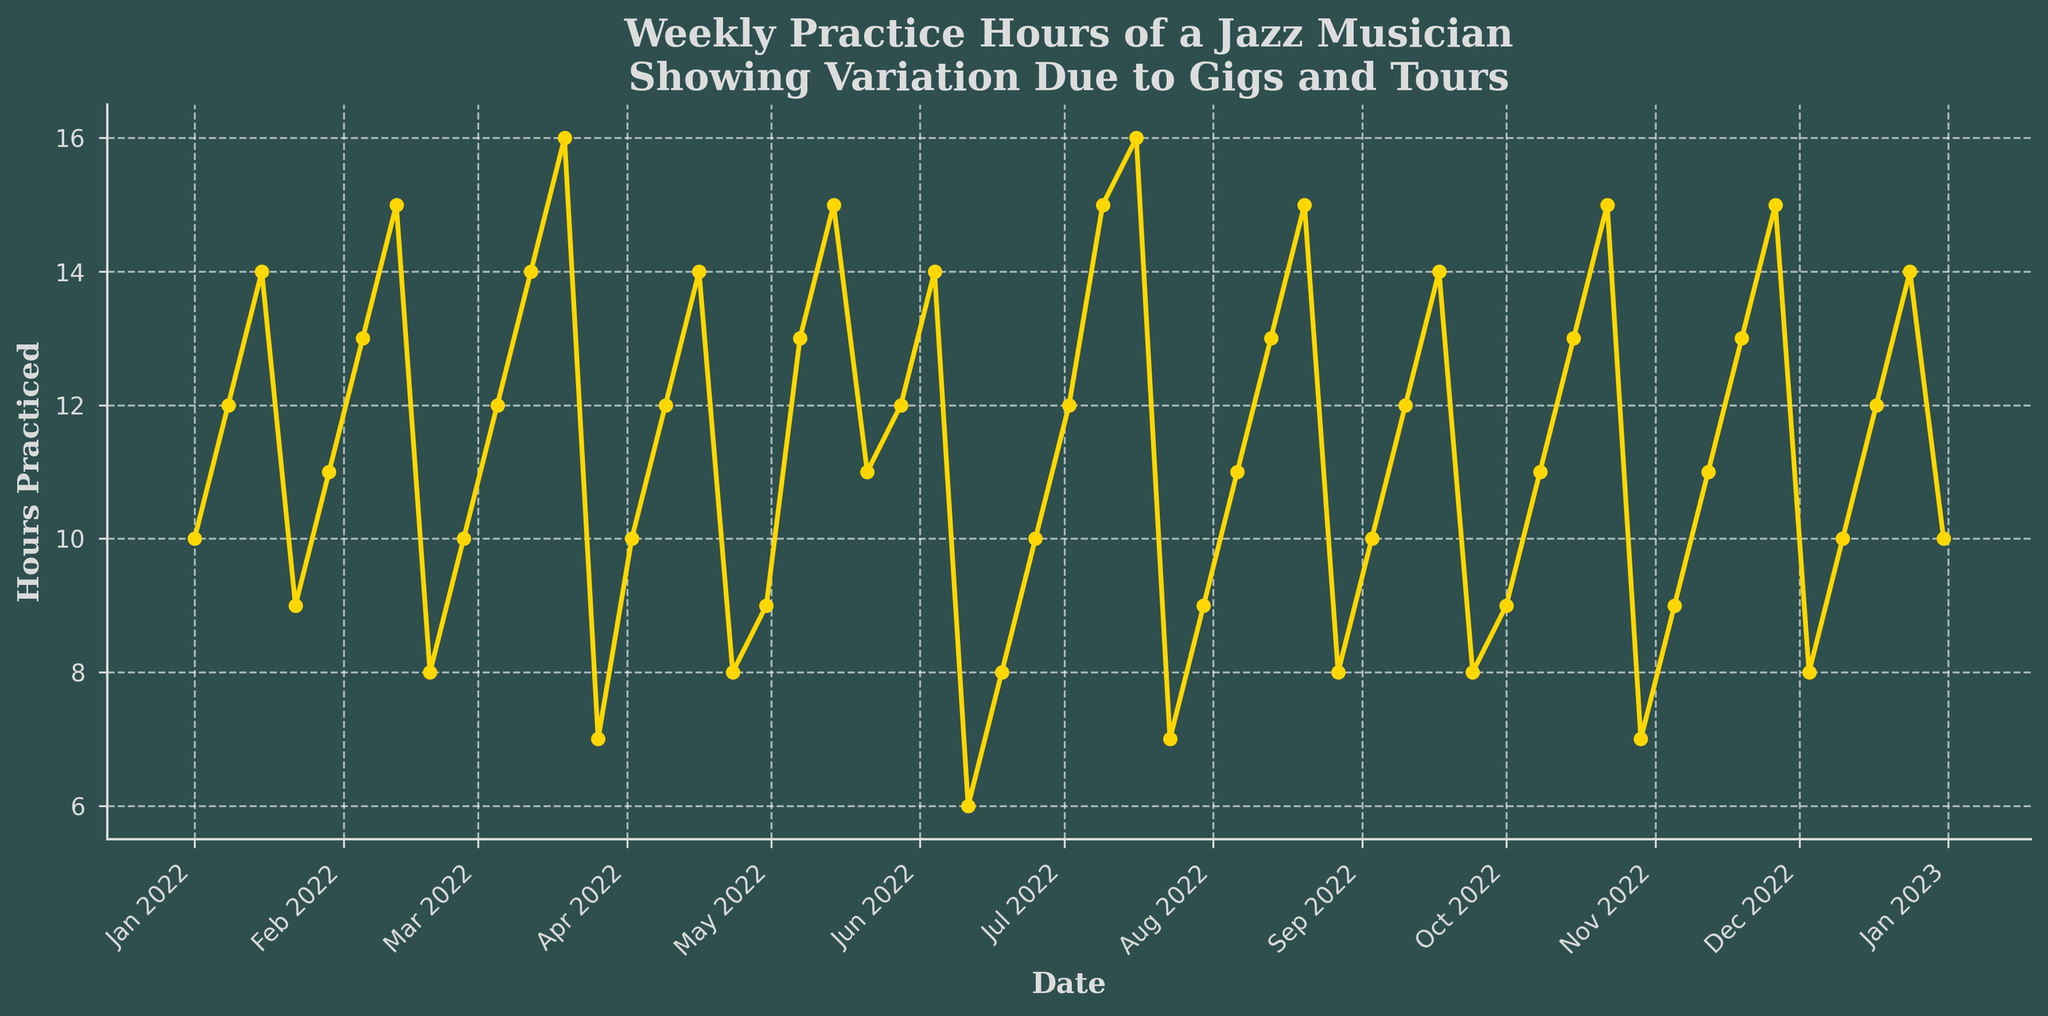How many total hours were practiced in February 2022? To find the total hours practiced in February 2022, sum the hours for each week in February: 13 (Feb 5) + 15 (Feb 12) + 8 (Feb 19) + 10 (Feb 26). The total hours are 13 + 15 + 8 + 10 = 46.
Answer: 46 Which week had the highest number of practice hours, and how many hours were practiced? Identify the maximum value on the y-axis representing practice hours and find the corresponding date on the x-axis. The highest number of practice hours is 16, which occurred on Mar 19 and Jul 16.
Answer: Mar 19 and Jul 16, 16 hours What is the average weekly practice hours in the first quarter of 2022? The first quarter includes January, February, and March. Add up the weekly hours for these months and divide by the number of weeks (13 weeks): (10 + 12 + 14 + 9 + 11 + 13 + 15 + 8 + 10 + 12 + 14 + 16 + 7) = 141. The average is 141 / 13 = 10.85.
Answer: 10.85 How did the practice hours change from the first week of January to the last week of December? Subtract the number of hours in the first week of January (10 hours) from the number of hours in the last week of December (10 hours). The change is 10 - 10 = 0 hours.
Answer: 0 Compare the practice hours in June and July. Which month had more total practice hours, and by how much? Sum the practice hours for each week in June: 13 (Jun 4) + 6 (Jun 11) + 8 (Jun 18) + 10 (Jun 25) = 37 hours. Sum the practice hours for each week in July: 12 (Jul 2) + 15 (Jul 9) + 16 (Jul 16) + 7 (Jul 23) + 9 (Jul 30) = 59 hours. July has more practice hours than June by 59 - 37 = 22 hours.
Answer: July, 22 hours What pattern can you observe in the practice hours leading up to and following a noticeable drop? Identify significant drops in practice hours and observe the surrounding values. For instance, prior to Mar 26 (7 hours), hours were stable or increasing (12, 14, 16), and the drop is followed by a return to higher values (10, 12, 14). This pattern suggests occasional interruptions possibly due to gigs or tours, but practice hours often rebound.
Answer: Sharp drops are followed by rebounds 